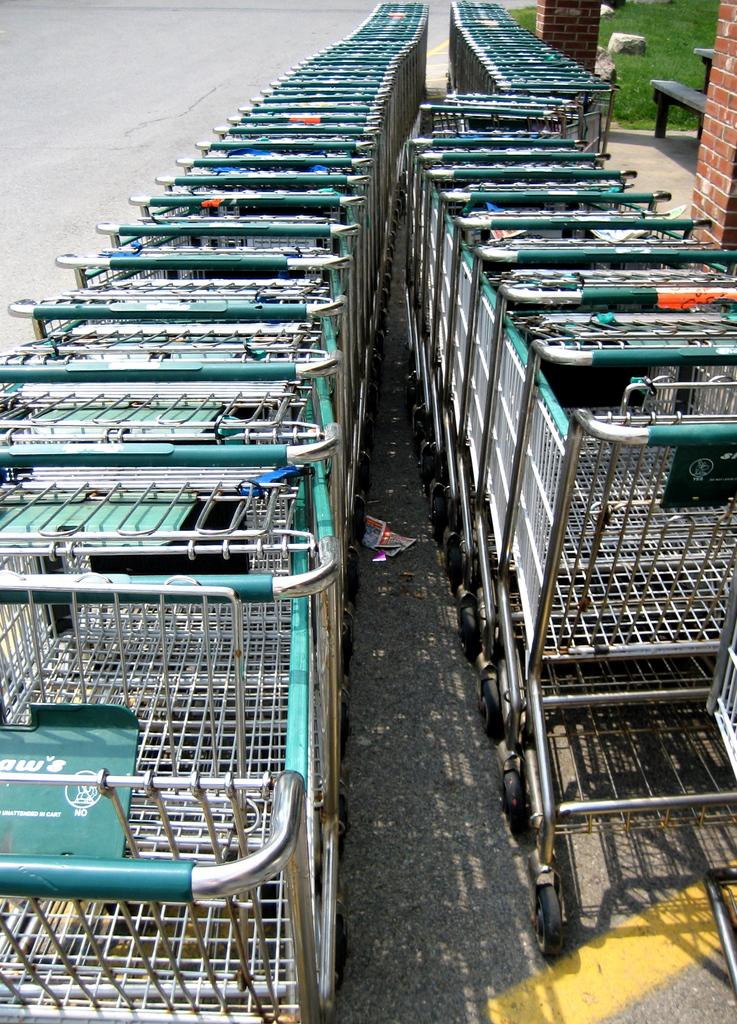Hat word is written under the circle on the cart child seat?
Provide a short and direct response. No. 